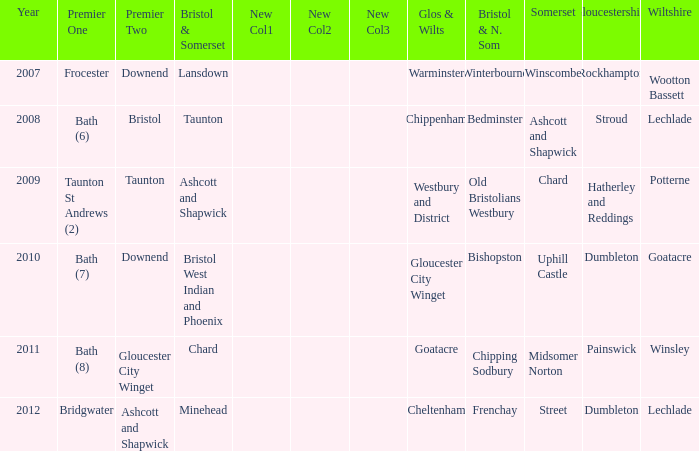What is the latest year where glos & wilts is warminster? 2007.0. 